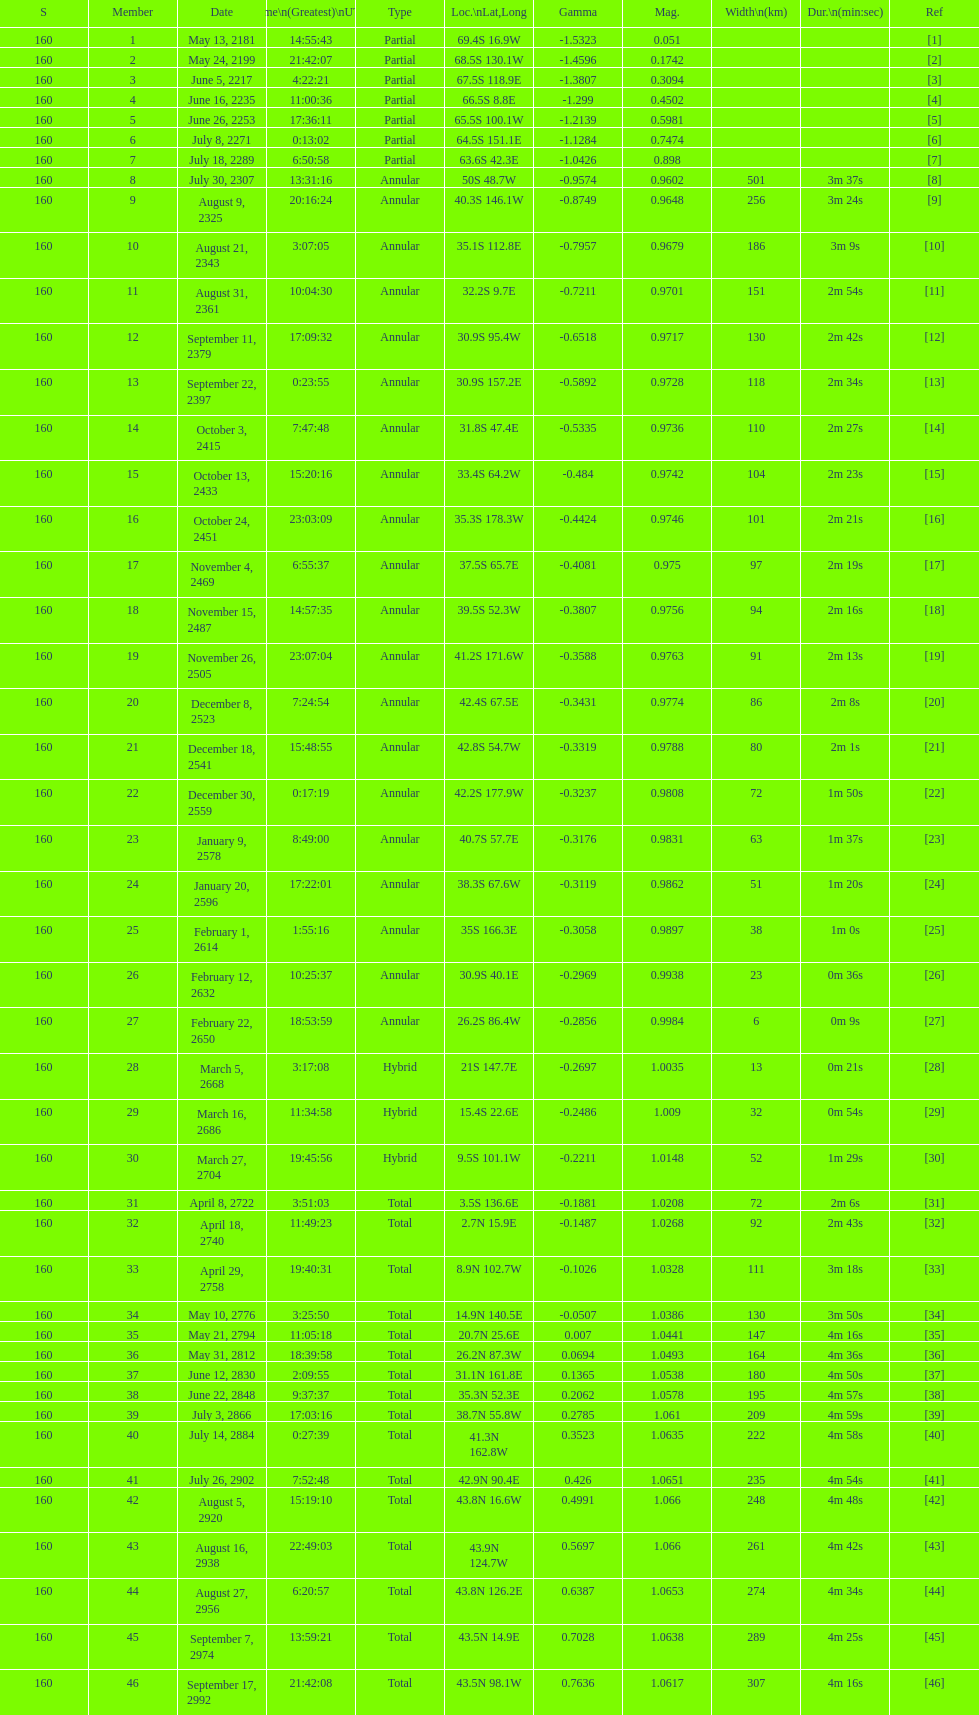How long did the the saros on july 30, 2307 last for? 3m 37s. 